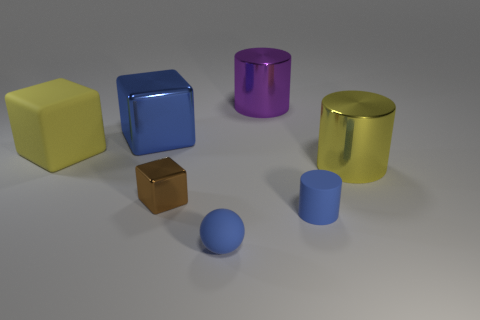Is there a brown shiny block of the same size as the yellow cylinder?
Your answer should be very brief. No. How many cyan objects are either big things or tiny matte spheres?
Your answer should be compact. 0. How many big things are the same color as the tiny sphere?
Make the answer very short. 1. Is there anything else that is the same shape as the brown metal object?
Your response must be concise. Yes. What number of cubes are either large matte things or tiny brown objects?
Provide a short and direct response. 2. What color is the metallic cylinder to the left of the yellow metal thing?
Offer a very short reply. Purple. What shape is the purple metal thing that is the same size as the yellow metal cylinder?
Your response must be concise. Cylinder. There is a brown shiny thing; what number of blue rubber balls are to the left of it?
Provide a succinct answer. 0. What number of objects are either big gray balls or big yellow metal objects?
Keep it short and to the point. 1. There is a metallic object that is left of the purple metallic object and in front of the blue metallic cube; what shape is it?
Make the answer very short. Cube. 